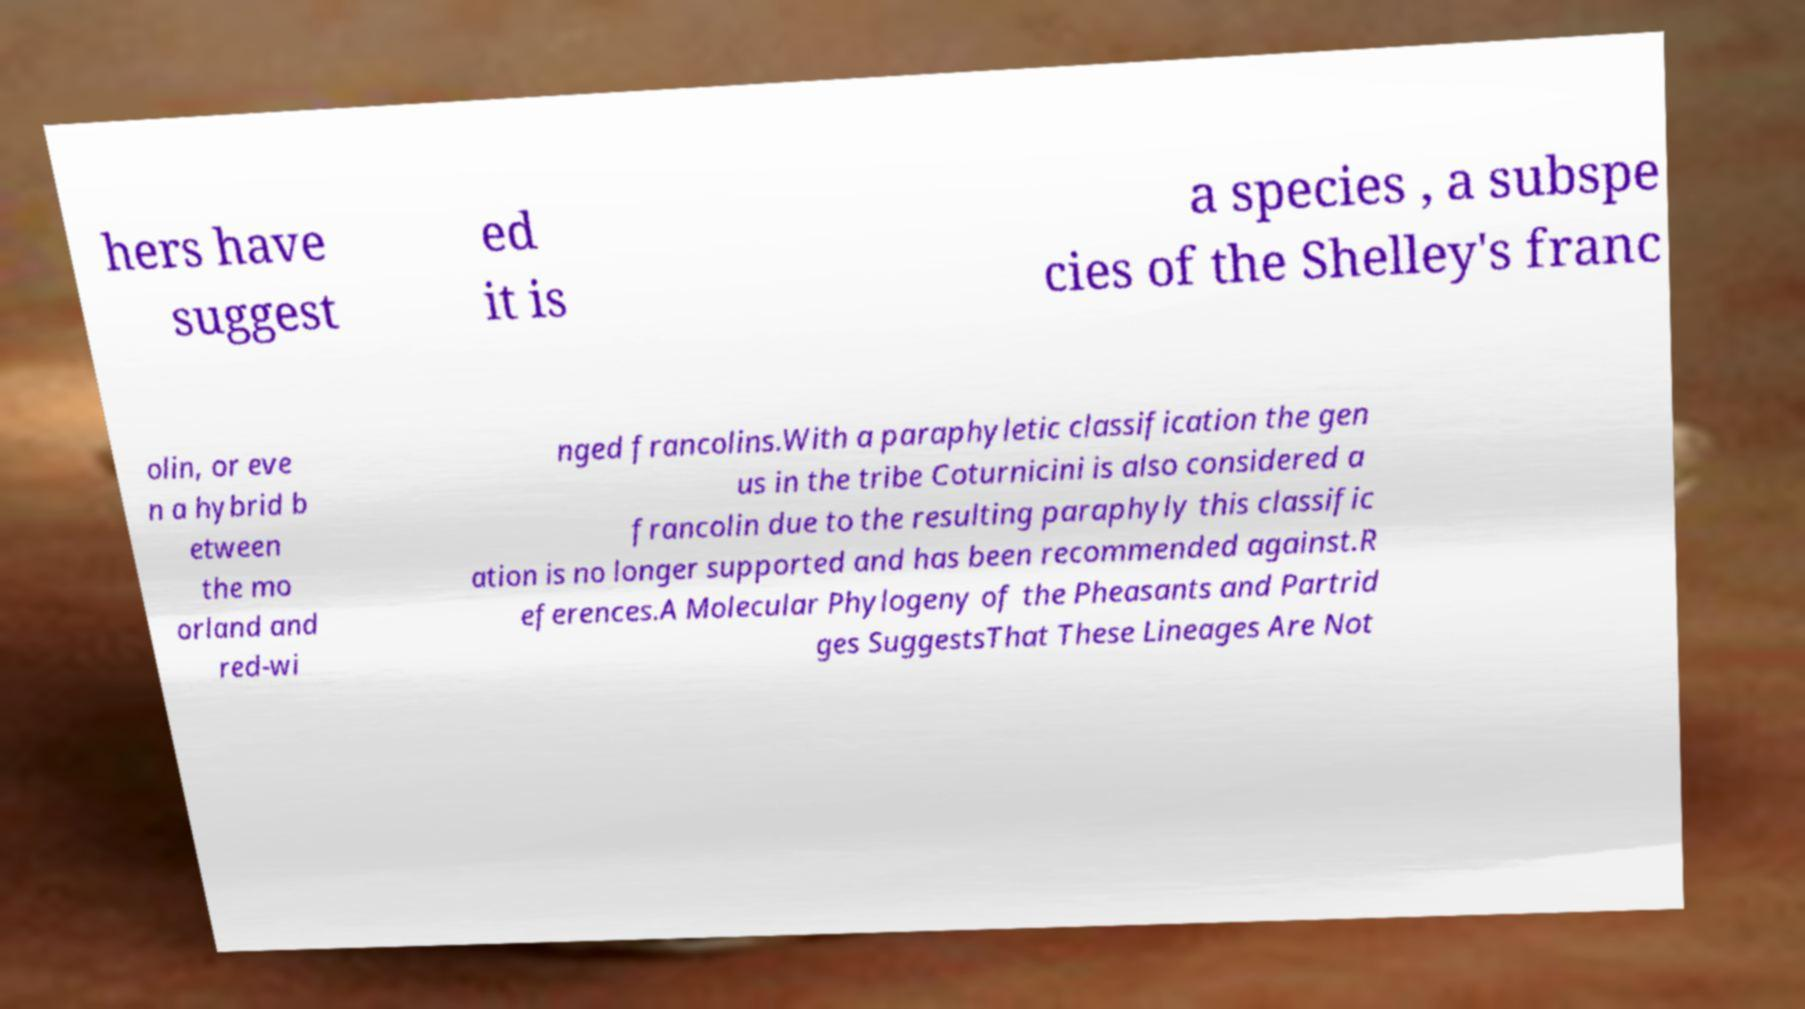There's text embedded in this image that I need extracted. Can you transcribe it verbatim? hers have suggest ed it is a species , a subspe cies of the Shelley's franc olin, or eve n a hybrid b etween the mo orland and red-wi nged francolins.With a paraphyletic classification the gen us in the tribe Coturnicini is also considered a francolin due to the resulting paraphyly this classific ation is no longer supported and has been recommended against.R eferences.A Molecular Phylogeny of the Pheasants and Partrid ges SuggestsThat These Lineages Are Not 